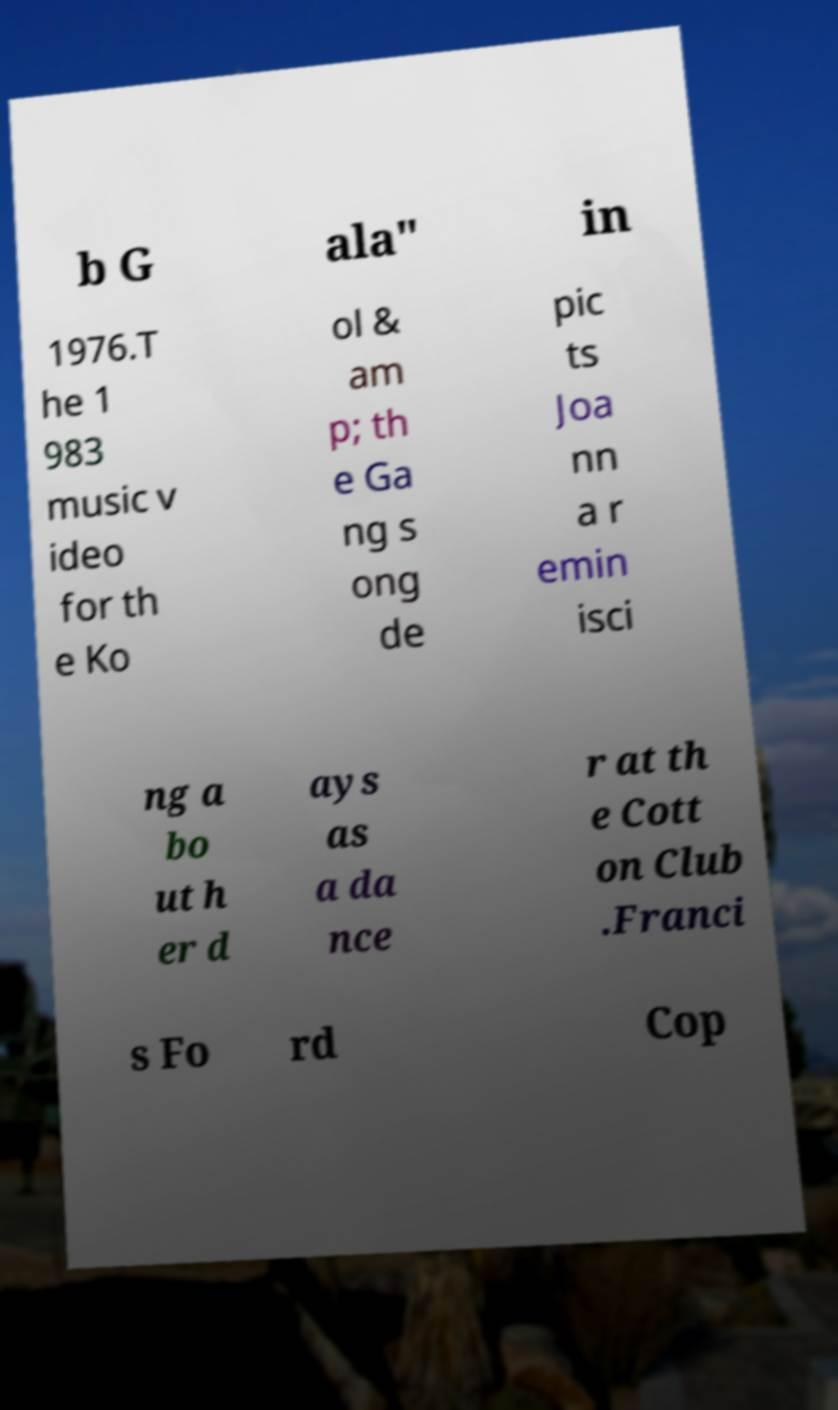Can you read and provide the text displayed in the image?This photo seems to have some interesting text. Can you extract and type it out for me? b G ala" in 1976.T he 1 983 music v ideo for th e Ko ol & am p; th e Ga ng s ong de pic ts Joa nn a r emin isci ng a bo ut h er d ays as a da nce r at th e Cott on Club .Franci s Fo rd Cop 